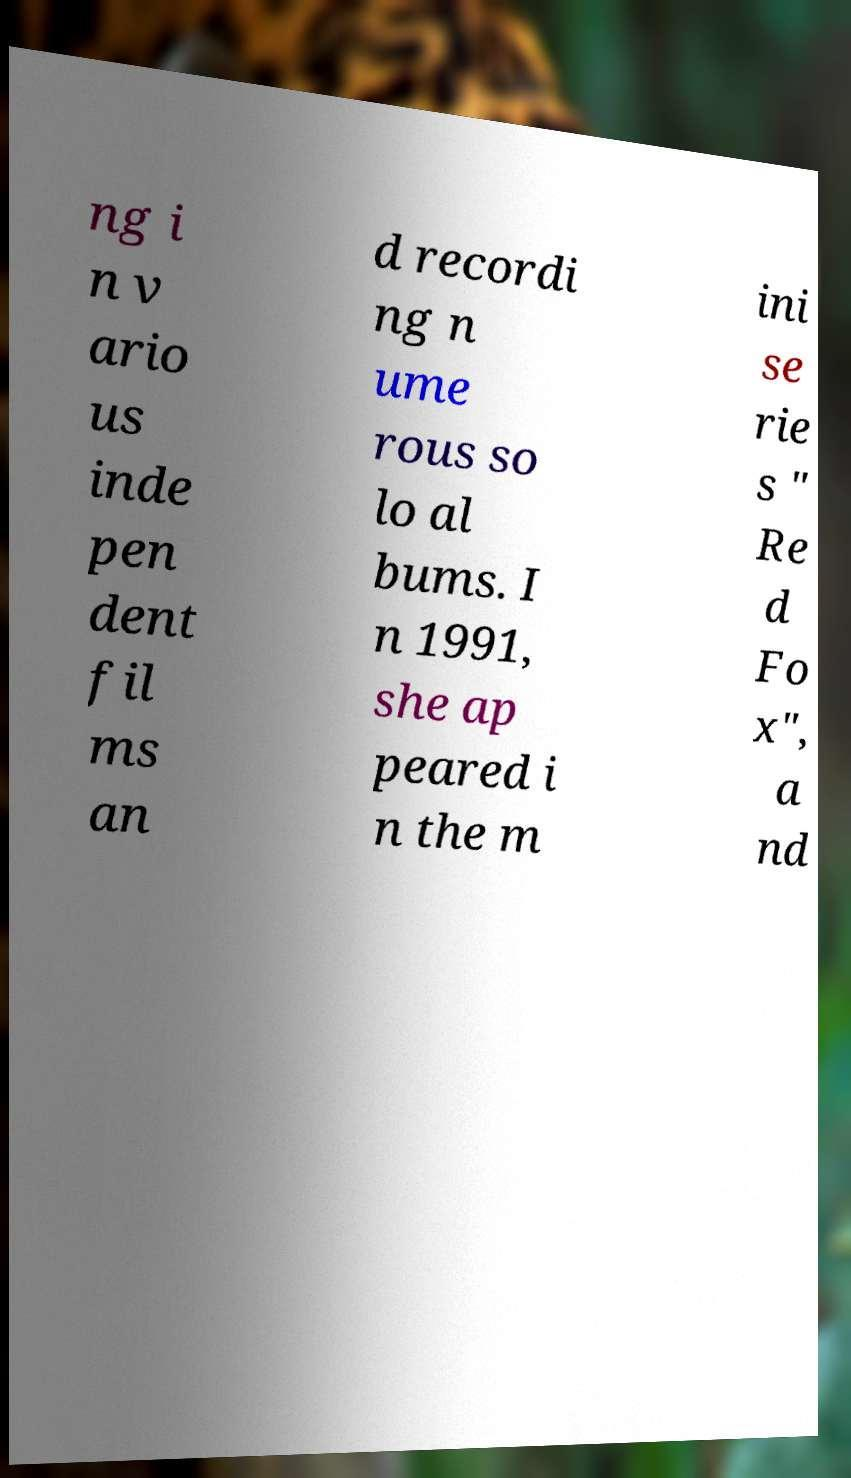Could you assist in decoding the text presented in this image and type it out clearly? ng i n v ario us inde pen dent fil ms an d recordi ng n ume rous so lo al bums. I n 1991, she ap peared i n the m ini se rie s " Re d Fo x", a nd 